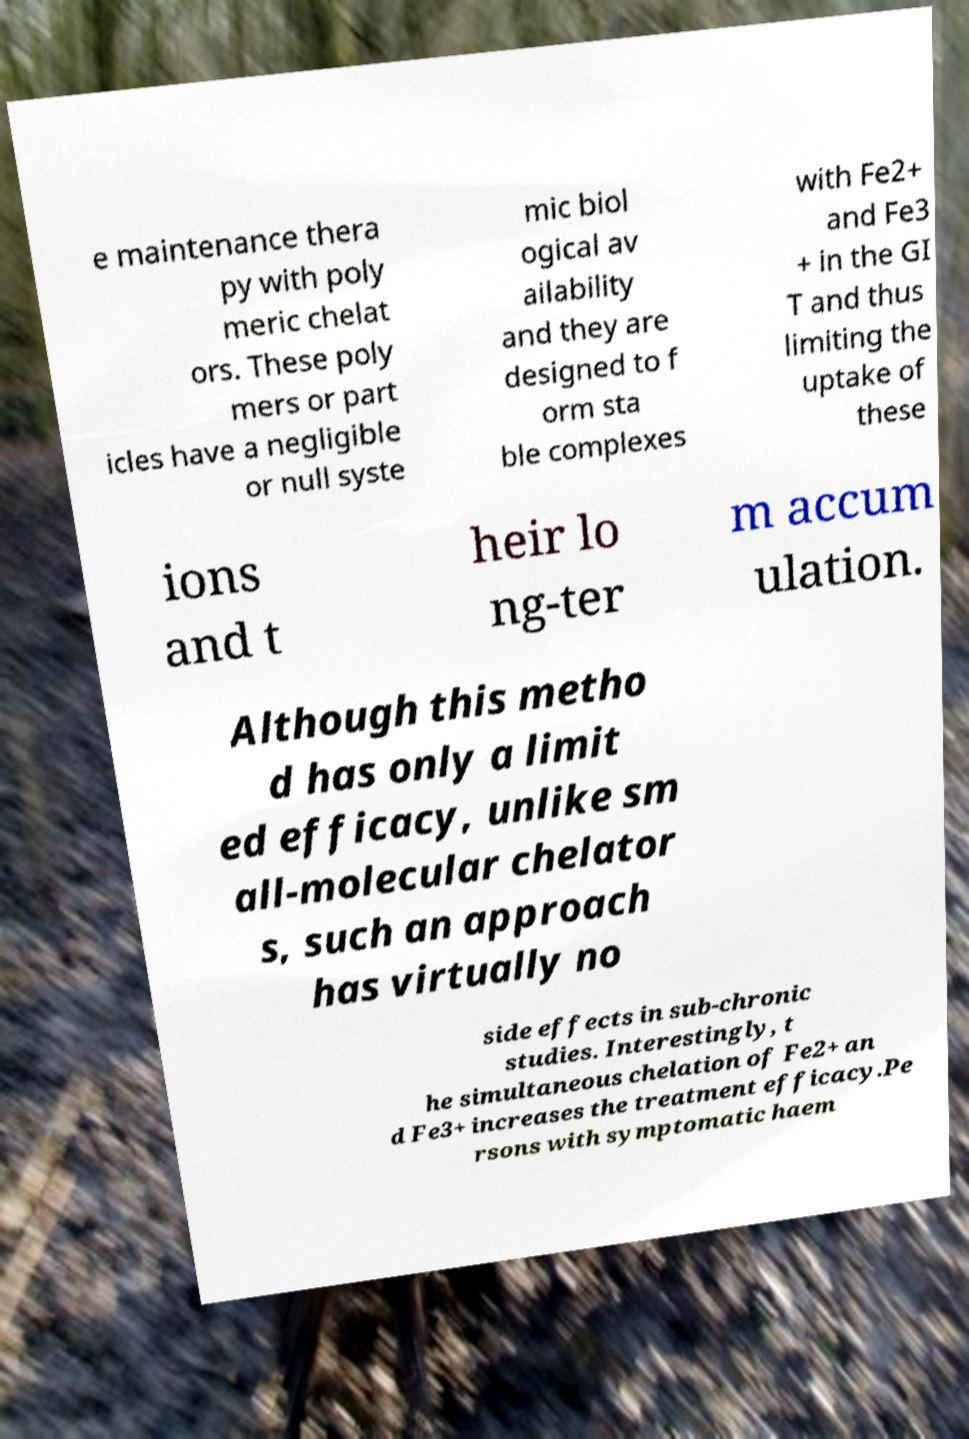What messages or text are displayed in this image? I need them in a readable, typed format. e maintenance thera py with poly meric chelat ors. These poly mers or part icles have a negligible or null syste mic biol ogical av ailability and they are designed to f orm sta ble complexes with Fe2+ and Fe3 + in the GI T and thus limiting the uptake of these ions and t heir lo ng-ter m accum ulation. Although this metho d has only a limit ed efficacy, unlike sm all-molecular chelator s, such an approach has virtually no side effects in sub-chronic studies. Interestingly, t he simultaneous chelation of Fe2+ an d Fe3+ increases the treatment efficacy.Pe rsons with symptomatic haem 